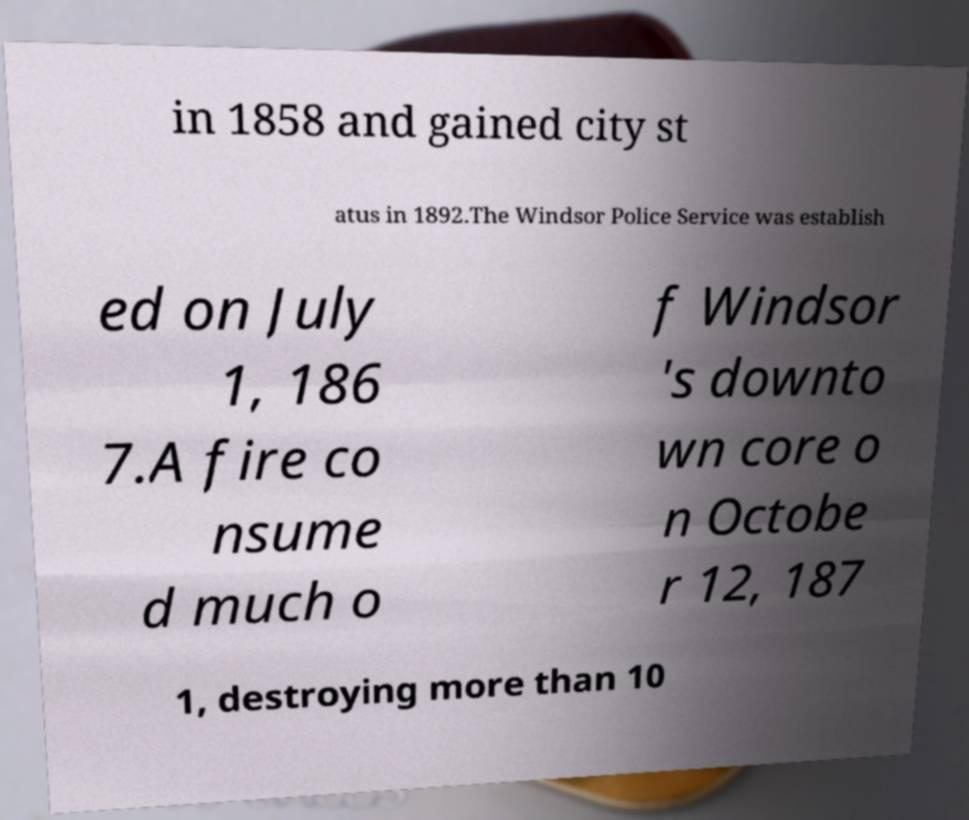There's text embedded in this image that I need extracted. Can you transcribe it verbatim? in 1858 and gained city st atus in 1892.The Windsor Police Service was establish ed on July 1, 186 7.A fire co nsume d much o f Windsor 's downto wn core o n Octobe r 12, 187 1, destroying more than 10 